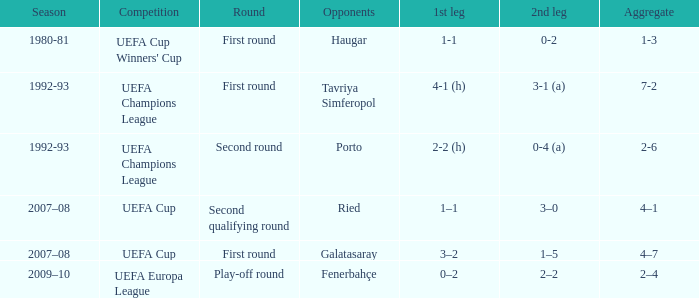What is the first leg in which the opposing team is galatasaray? 3–2. Would you be able to parse every entry in this table? {'header': ['Season', 'Competition', 'Round', 'Opponents', '1st leg', '2nd leg', 'Aggregate'], 'rows': [['1980-81', "UEFA Cup Winners' Cup", 'First round', 'Haugar', '1-1', '0-2', '1-3'], ['1992-93', 'UEFA Champions League', 'First round', 'Tavriya Simferopol', '4-1 (h)', '3-1 (a)', '7-2'], ['1992-93', 'UEFA Champions League', 'Second round', 'Porto', '2-2 (h)', '0-4 (a)', '2-6'], ['2007–08', 'UEFA Cup', 'Second qualifying round', 'Ried', '1–1', '3–0', '4–1'], ['2007–08', 'UEFA Cup', 'First round', 'Galatasaray', '3–2', '1–5', '4–7'], ['2009–10', 'UEFA Europa League', 'Play-off round', 'Fenerbahçe', '0–2', '2–2', '2–4']]} 